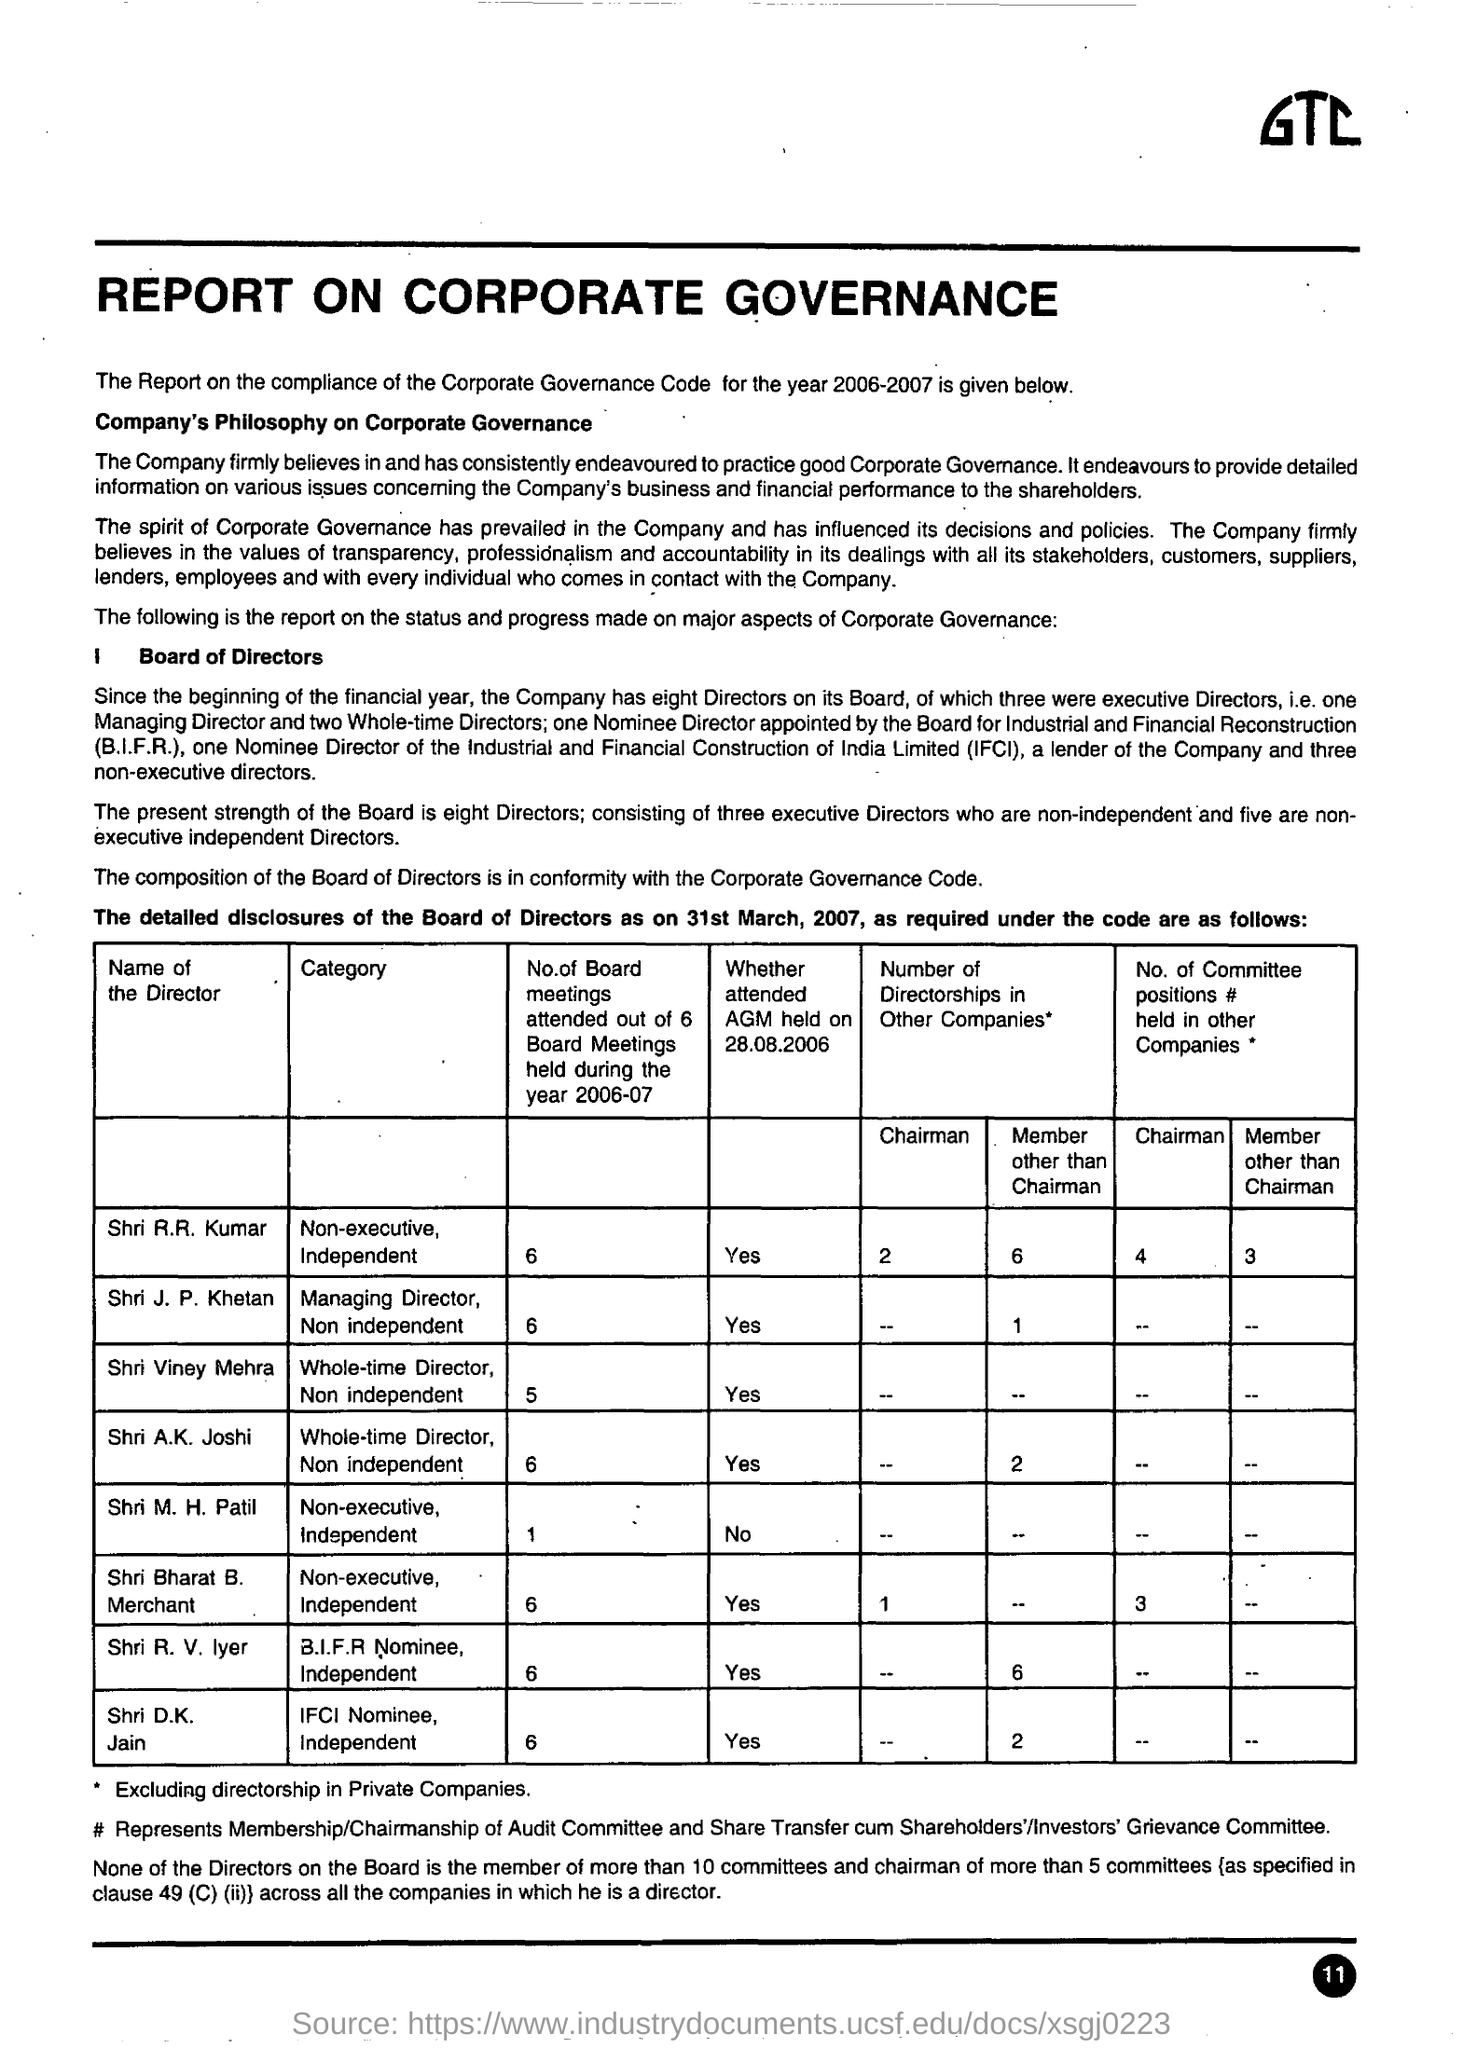How many directors are there on the Company Board ?
Your answer should be very brief. 8. What does IFCI stand for ?
Give a very brief answer. Industrial and Financial Construction of India Limited. What does B.I.F.R. stand for ?
Ensure brevity in your answer.  Board for Industrial and Financial Reconstruction. For which year is the report on the compliance of the corporate governance Code given?
Your answer should be very brief. 2006-2007. How many Board meetings have Shri M.H. Patil attended during the year 2006-07 ?
Provide a succinct answer. 1. How many executive directors are there in the board?
Give a very brief answer. Three. How many non-executive independent directors are there in the board?
Your answer should be very brief. 5. 